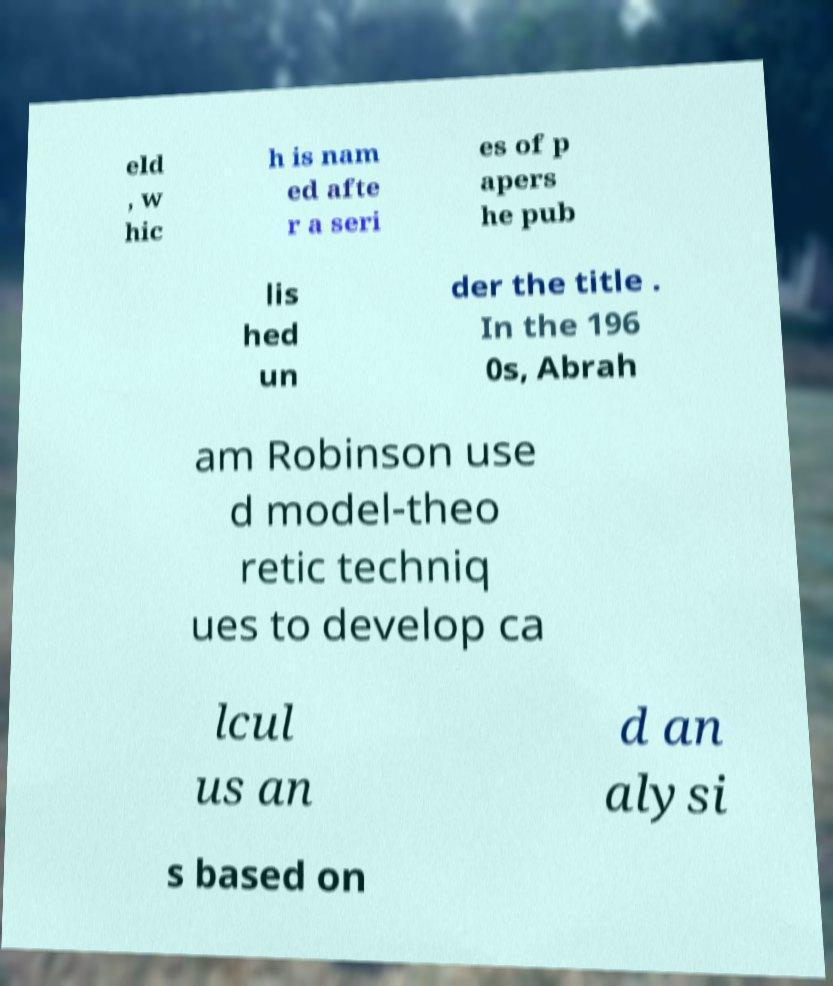Can you accurately transcribe the text from the provided image for me? eld , w hic h is nam ed afte r a seri es of p apers he pub lis hed un der the title . In the 196 0s, Abrah am Robinson use d model-theo retic techniq ues to develop ca lcul us an d an alysi s based on 